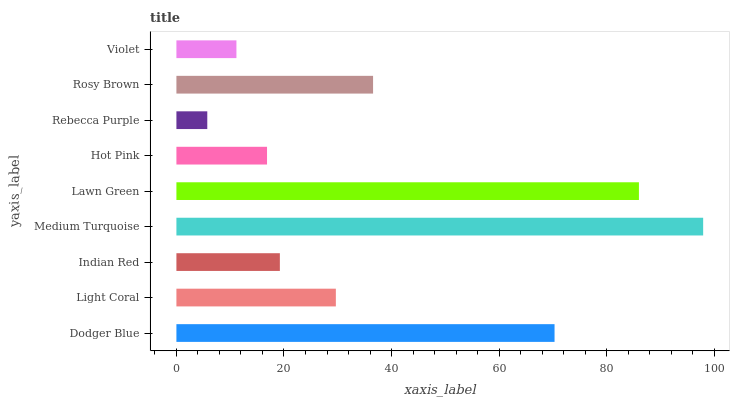Is Rebecca Purple the minimum?
Answer yes or no. Yes. Is Medium Turquoise the maximum?
Answer yes or no. Yes. Is Light Coral the minimum?
Answer yes or no. No. Is Light Coral the maximum?
Answer yes or no. No. Is Dodger Blue greater than Light Coral?
Answer yes or no. Yes. Is Light Coral less than Dodger Blue?
Answer yes or no. Yes. Is Light Coral greater than Dodger Blue?
Answer yes or no. No. Is Dodger Blue less than Light Coral?
Answer yes or no. No. Is Light Coral the high median?
Answer yes or no. Yes. Is Light Coral the low median?
Answer yes or no. Yes. Is Medium Turquoise the high median?
Answer yes or no. No. Is Hot Pink the low median?
Answer yes or no. No. 